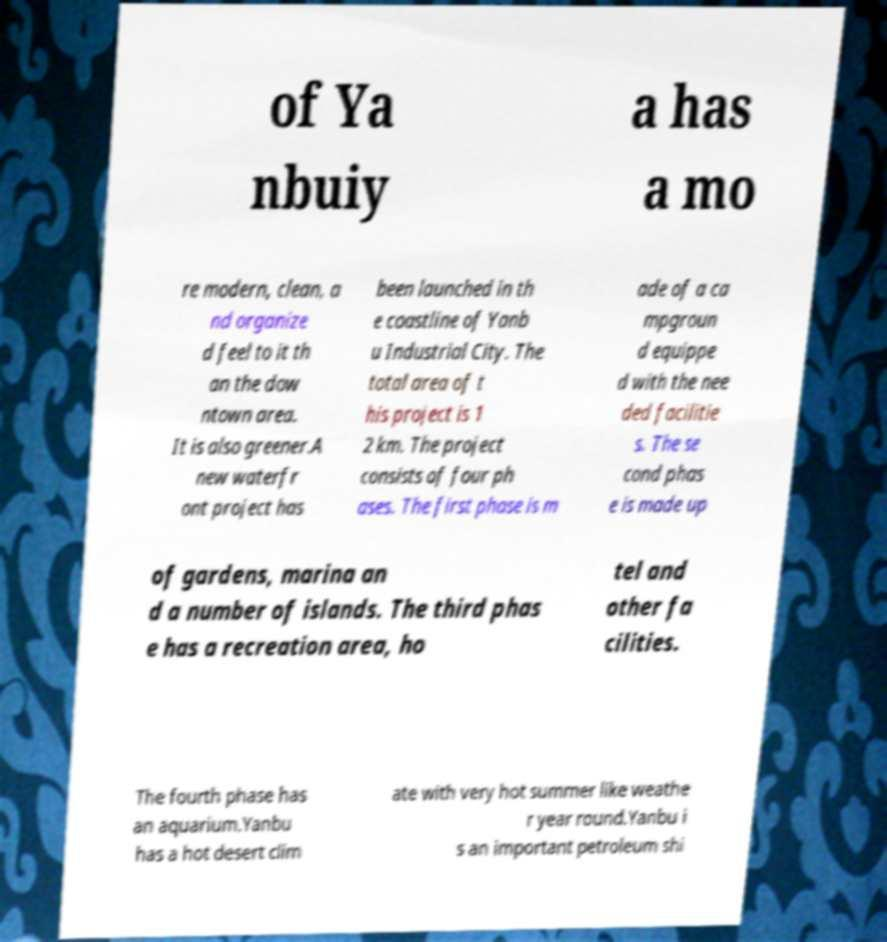Can you accurately transcribe the text from the provided image for me? of Ya nbuiy a has a mo re modern, clean, a nd organize d feel to it th an the dow ntown area. It is also greener.A new waterfr ont project has been launched in th e coastline of Yanb u Industrial City. The total area of t his project is 1 2 km. The project consists of four ph ases. The first phase is m ade of a ca mpgroun d equippe d with the nee ded facilitie s. The se cond phas e is made up of gardens, marina an d a number of islands. The third phas e has a recreation area, ho tel and other fa cilities. The fourth phase has an aquarium.Yanbu has a hot desert clim ate with very hot summer like weathe r year round.Yanbu i s an important petroleum shi 